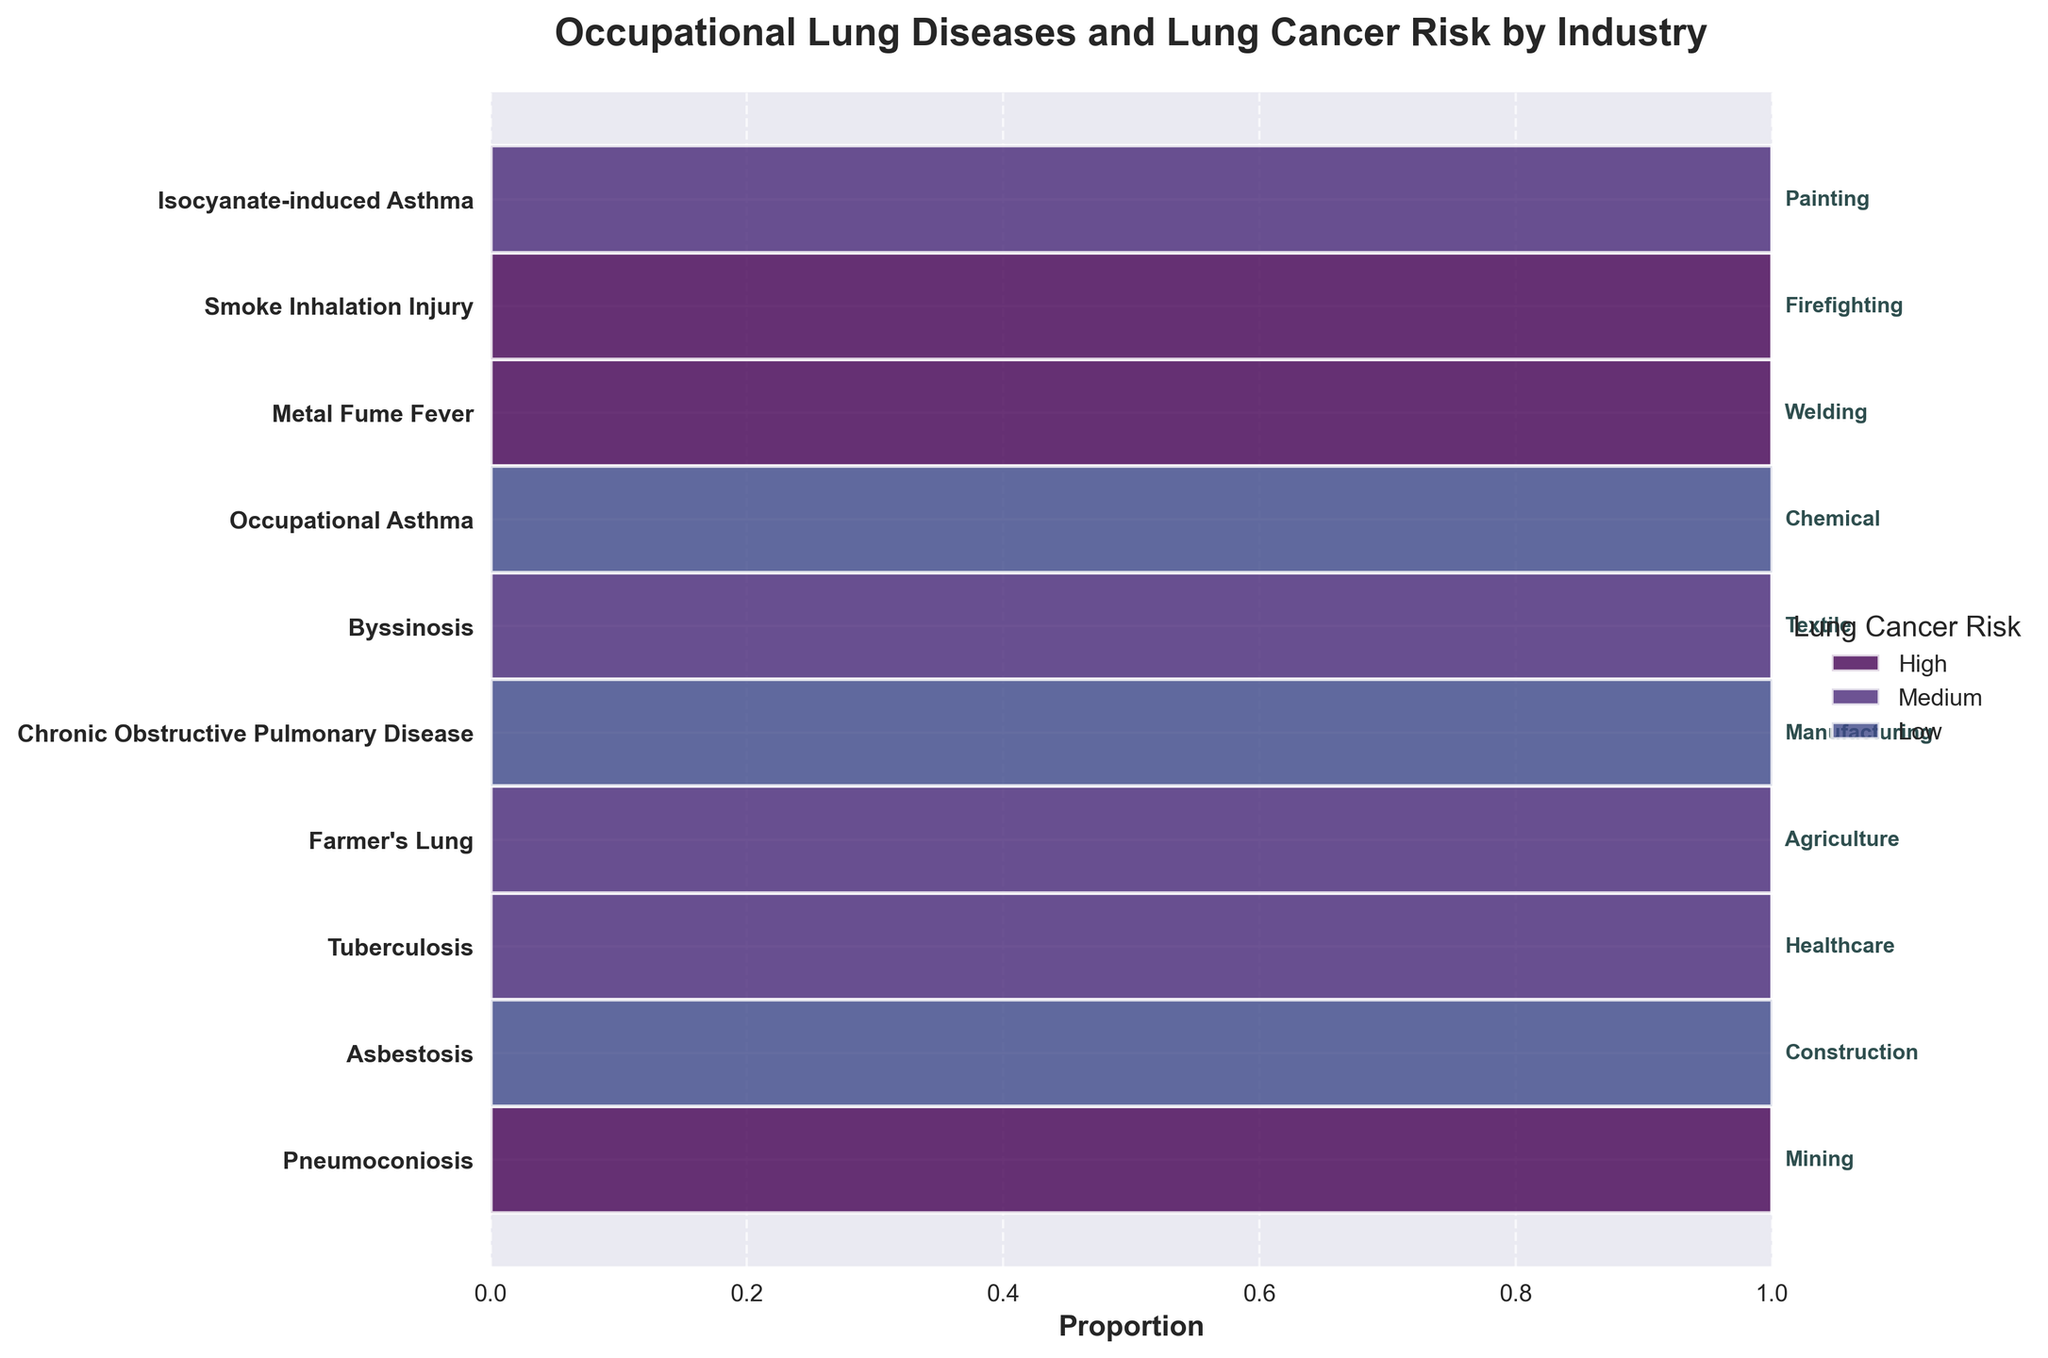What is the title of the plot? The title of the plot is displayed at the top of the figure. It summarizes what the chart is about, namely the relationship between occupational lung diseases and lung cancer risk by industry.
Answer: Occupational Lung Diseases and Lung Cancer Risk by Industry Which lung disease has the highest association with a high lung cancer risk? Looking at the regions labeled as "High" in the mosaic plot and finding the corresponding lung disease on the y-axis, we see that Pneumoconiosis in Mining has one of the largest proportions in the high-risk category.
Answer: Pneumoconiosis Is there any industry where the lung cancer risk is low for the associated occupational lung disease? Check the bars labeled "Low" in the mosaic plot and see which industries they correspond to. Textile (Byssinosis), Chemical (Occupational Asthma), and Painting (Isocyanate-induced Asthma) have low-risk associations.
Answer: Textile, Chemical, Painting How many industries have a medium lung cancer risk for their associated occupational lung disease? Count the industries associated with "Medium" in the mosaic plot. These are healthcare (Tuberculosis), agriculture (Farmer's Lung), manufacturing (Chronic Obstructive Pulmonary Disease), and welding (Metal Fume Fever).
Answer: 4 Which industry with a high cancer risk has the smallest proportion? Among the bars labeled "High," the smallest bar in terms of width corresponds to Firefighting (Smoke Inhalation Injury).
Answer: Firefighting For which lung disease is the lung cancer risk in the "High" category the highest proportion compared to medium and low categories? Locate the lung disease whose width of the "High" bar is the largest compared to its "Medium" and "Low" bars. Pneumoconiosis in Mining will likely have the most significant proportion in the high-risk category.
Answer: Pneumoconiosis 